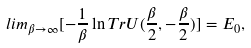Convert formula to latex. <formula><loc_0><loc_0><loc_500><loc_500>l i m _ { \beta \to \infty } [ - \frac { 1 } { \beta } \ln T r U ( \frac { \beta } { 2 } , - \frac { \beta } { 2 } ) ] = E _ { 0 } ,</formula> 